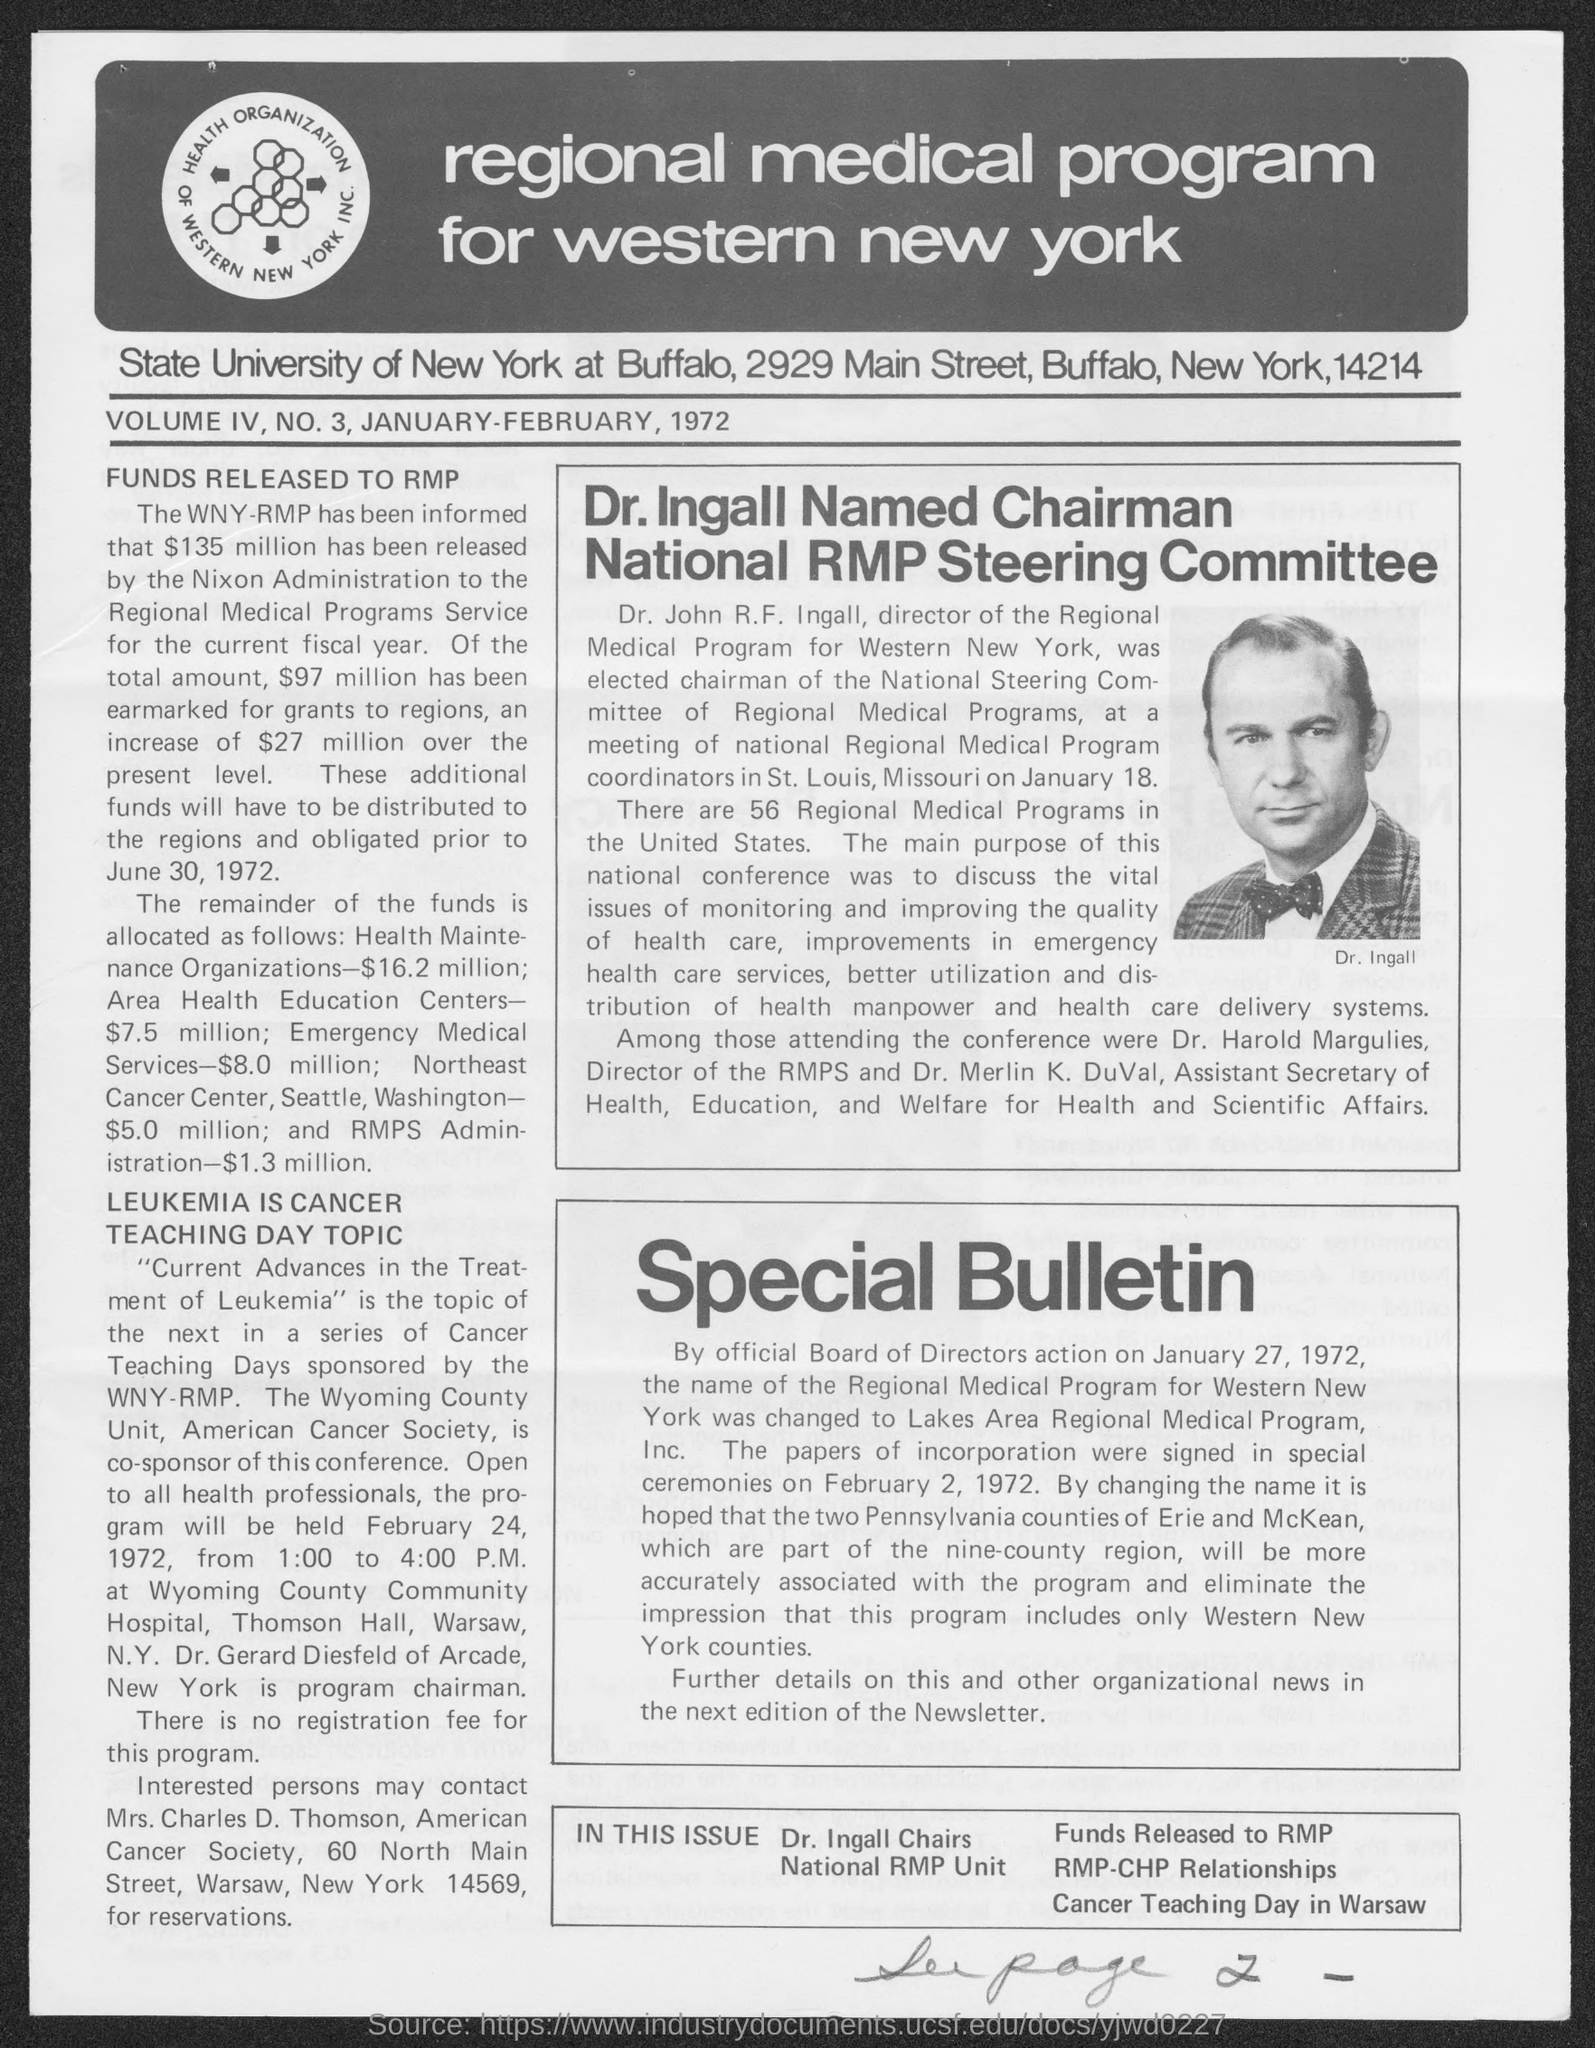Outline some significant characteristics in this image. The State University of New York is located in the state of New York. 